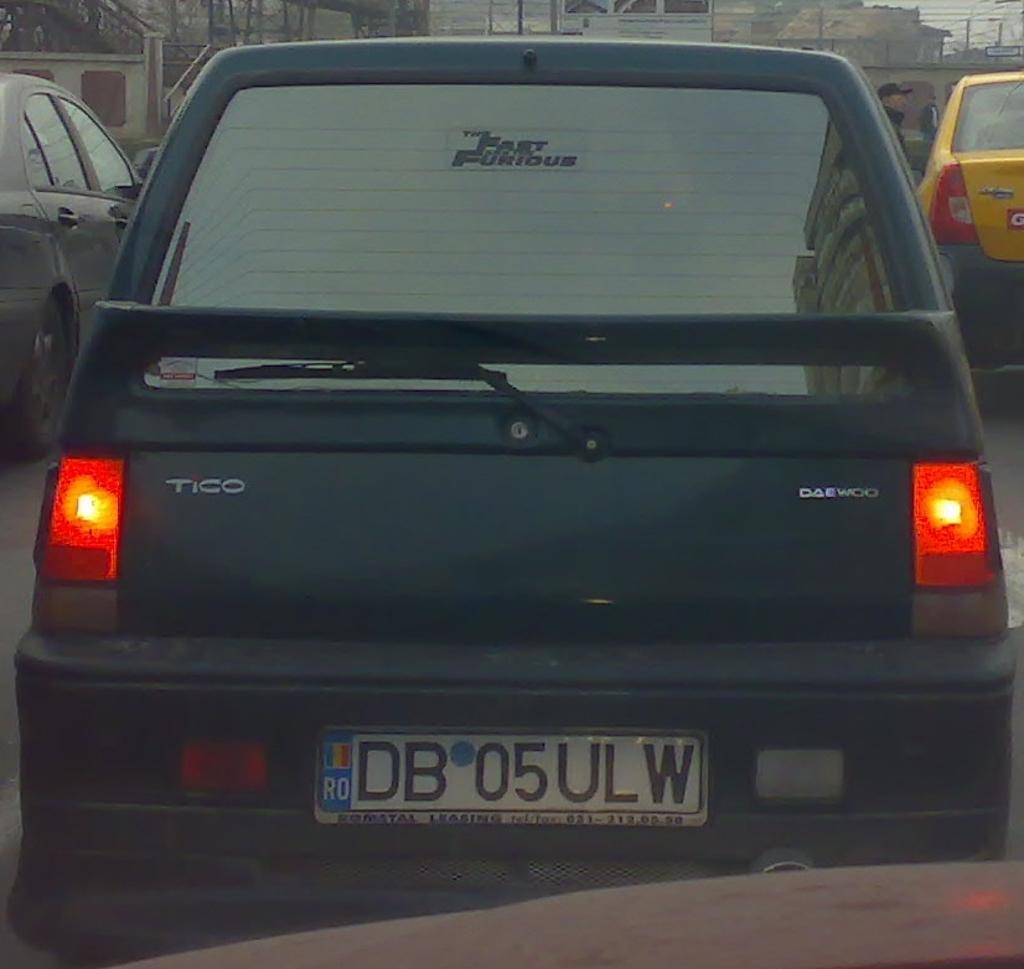<image>
Create a compact narrative representing the image presented. A Daewoo vehicle has a license plate number DB 05ULW. 